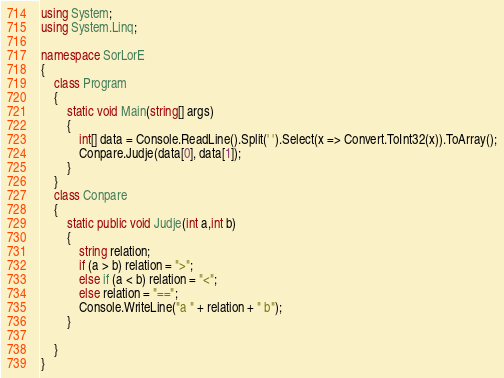<code> <loc_0><loc_0><loc_500><loc_500><_C#_>using System;
using System.Linq;

namespace SorLorE
{
    class Program
    {
        static void Main(string[] args)
        {
            int[] data = Console.ReadLine().Split(' ').Select(x => Convert.ToInt32(x)).ToArray();
            Conpare.Judje(data[0], data[1]);
        }
    }
    class Conpare
    {
        static public void Judje(int a,int b)
        {
            string relation;
            if (a > b) relation = ">";
            else if (a < b) relation = "<";
            else relation = "==";
            Console.WriteLine("a " + relation + " b");
        }

    }
}</code> 